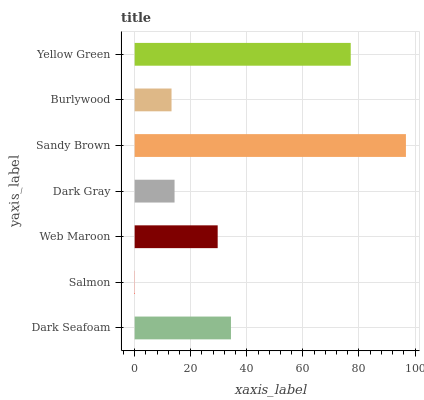Is Salmon the minimum?
Answer yes or no. Yes. Is Sandy Brown the maximum?
Answer yes or no. Yes. Is Web Maroon the minimum?
Answer yes or no. No. Is Web Maroon the maximum?
Answer yes or no. No. Is Web Maroon greater than Salmon?
Answer yes or no. Yes. Is Salmon less than Web Maroon?
Answer yes or no. Yes. Is Salmon greater than Web Maroon?
Answer yes or no. No. Is Web Maroon less than Salmon?
Answer yes or no. No. Is Web Maroon the high median?
Answer yes or no. Yes. Is Web Maroon the low median?
Answer yes or no. Yes. Is Yellow Green the high median?
Answer yes or no. No. Is Dark Seafoam the low median?
Answer yes or no. No. 